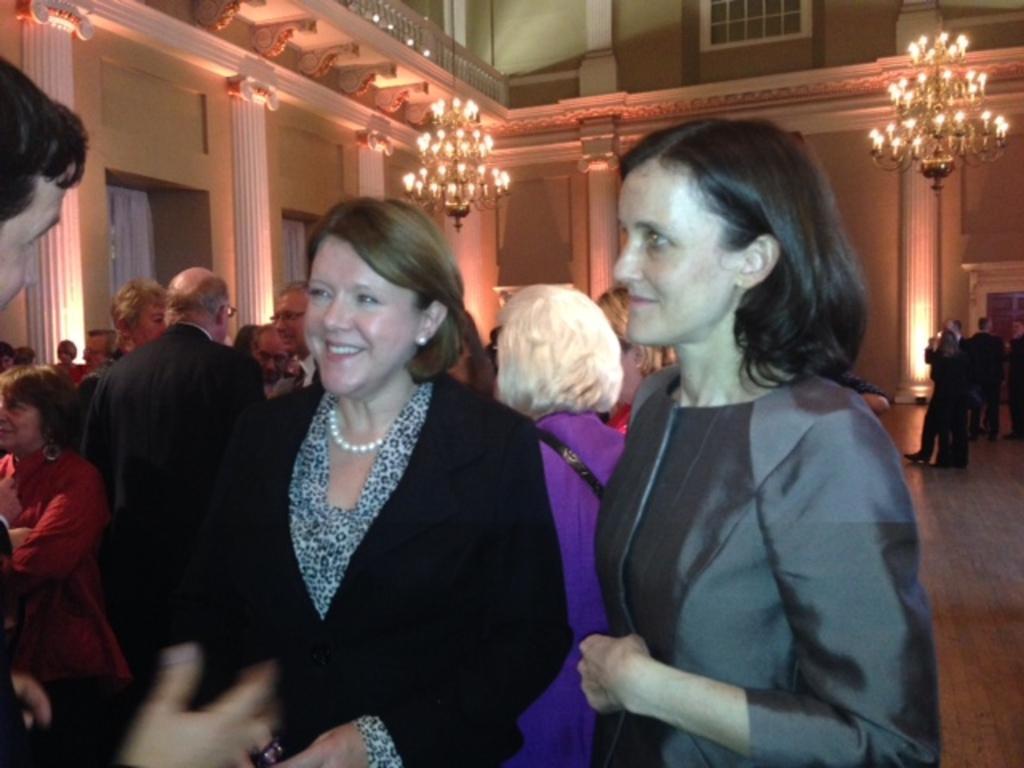Please provide a concise description of this image. In this image I can see group of people standing. In front the person is wearing black color blazer. In the background I can see two chandeliers, few dollars and few curtains. 